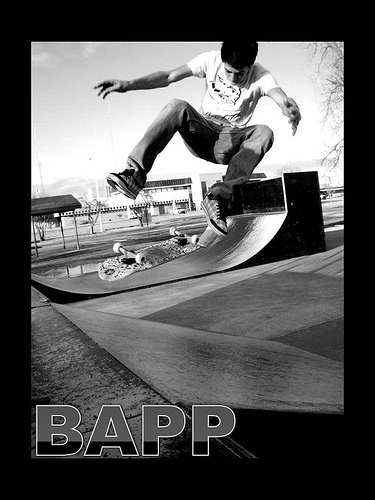World skate is the head controller of which sport?
A. surfing
B. swimming
C. skiing
D. skating
Answer with the option's letter from the given choices directly. D. Skating is the correct answer. World Skate is the international governing body for roller sports and has been recognized by the International Olympic Committee as such. It oversees multiple disciplines within skating, including skateboarding, roller freestyle, downhill, roller hockey, and more. The image shows a skateboarder performing a trick on a ramp, which falls under the purview of World Skate. 